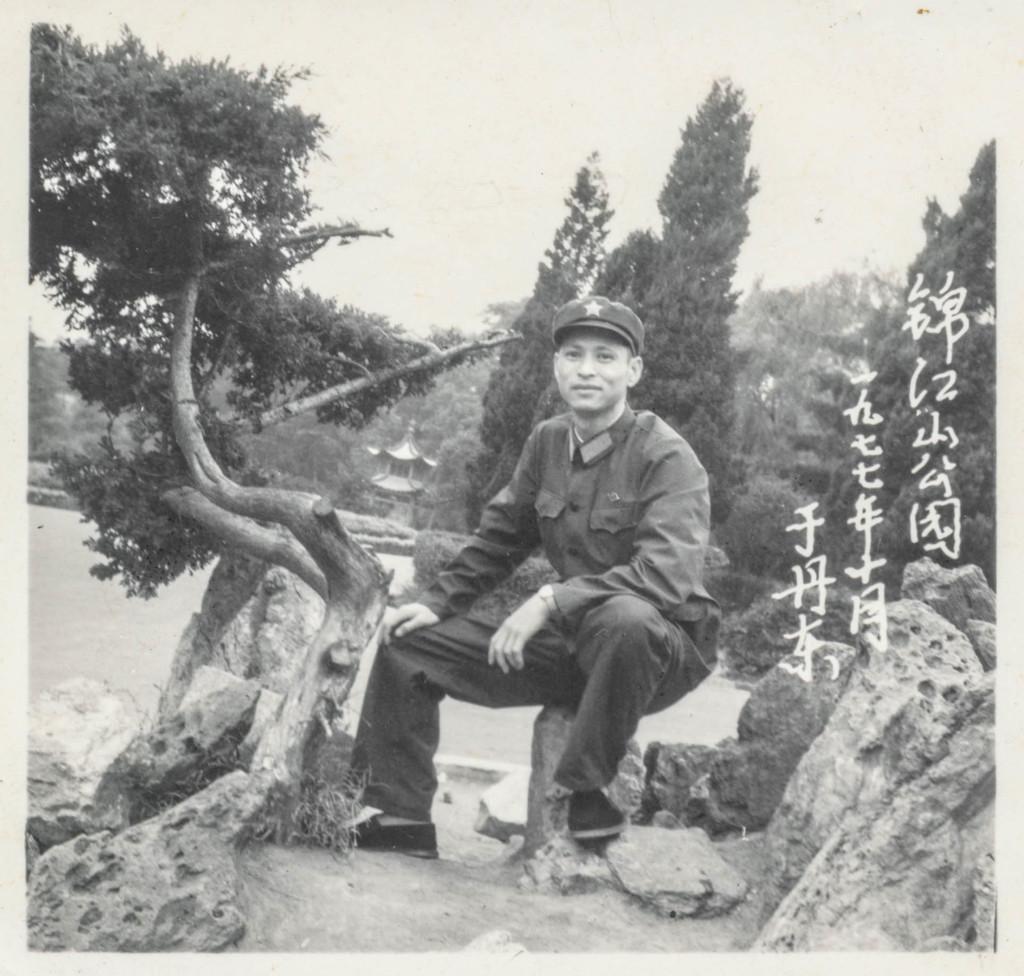Please provide a concise description of this image. In this image there is a person sitting on the rock , and in the background there are trees, building and there is a watermark on the image. 